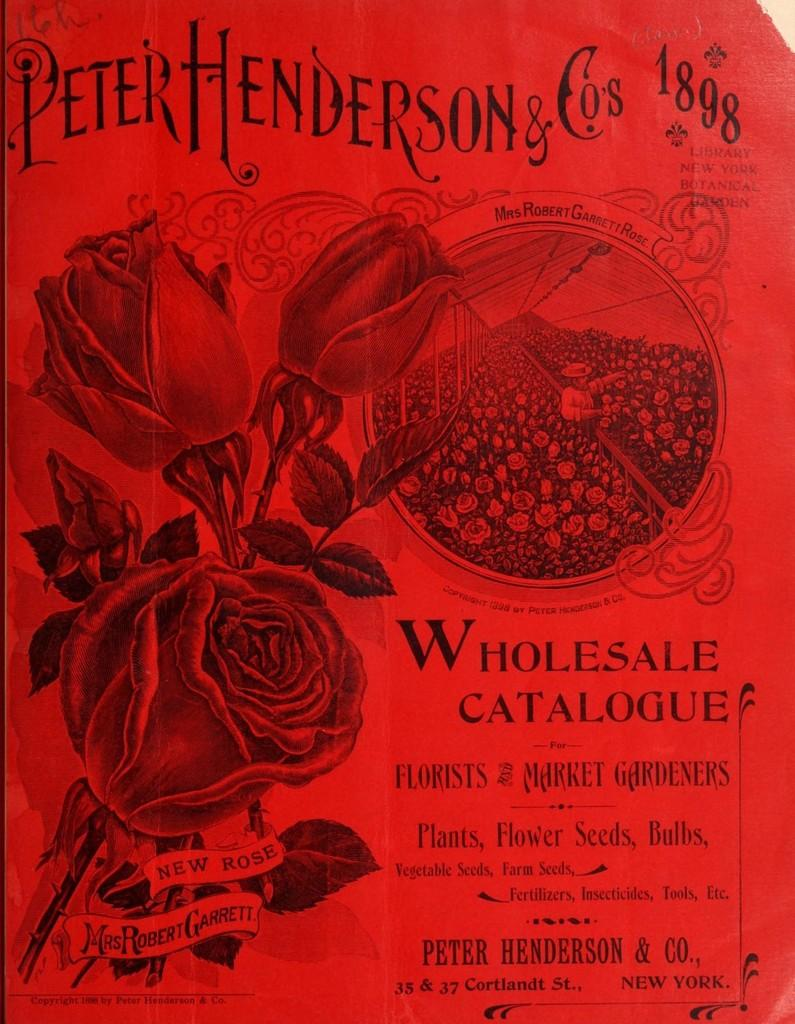What type of flowers are on the left side of the image? There are three roses on the left side of the image. What can be found on the right side of the image? There is text or content written on the right side of the image. How many coughs can be heard in the image? There are no coughs present in the image, as it is a visual representation and not an audio recording. 